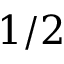<formula> <loc_0><loc_0><loc_500><loc_500>1 / 2</formula> 